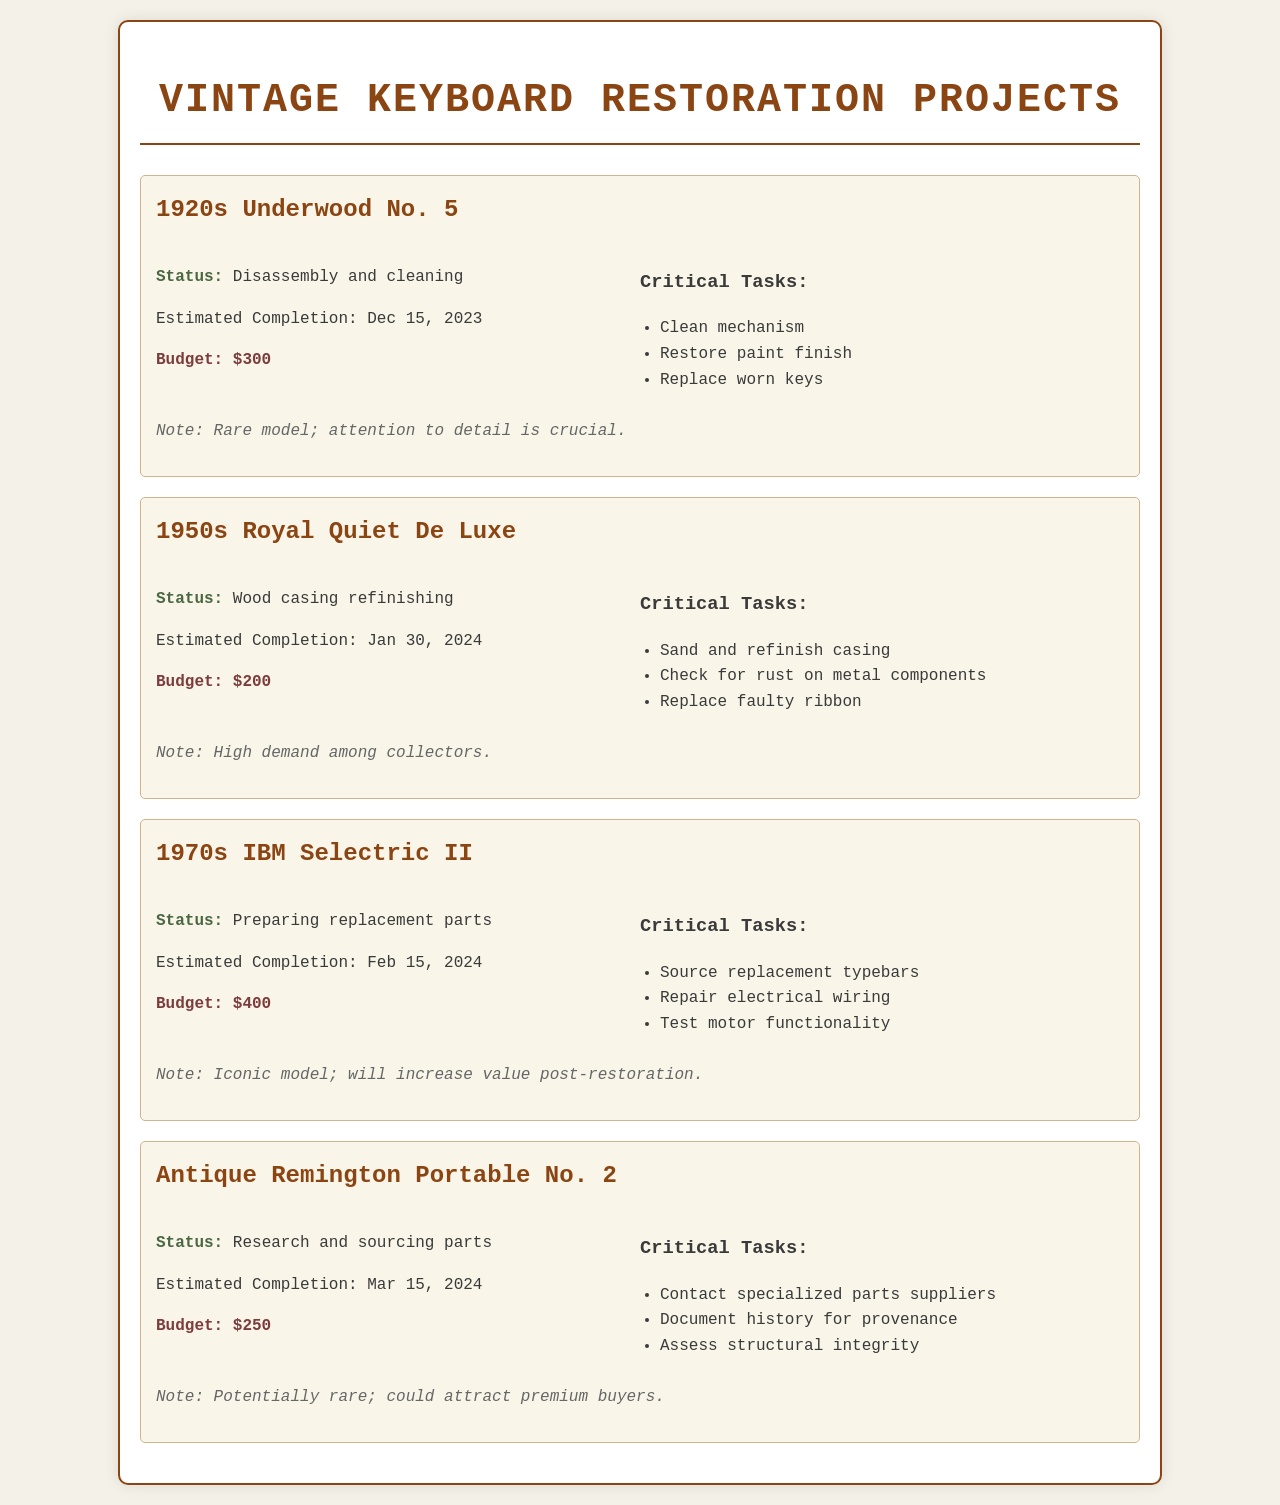what is the status of the 1920s Underwood No. 5? The status is indicated as the current phase of restoration in the document, which is "Disassembly and cleaning."
Answer: Disassembly and cleaning what is the estimated completion date for the 1950s Royal Quiet De Luxe? The estimated completion date is provided in the document, which states it will be completed on "Jan 30, 2024."
Answer: Jan 30, 2024 how much is allocated for the budget of the 1970s IBM Selectric II? The budget is specified in the project details as "$400."
Answer: $400 what critical task is associated with the Antique Remington Portable No. 2? Critical tasks are listed, one of which is "Contact specialized parts suppliers."
Answer: Contact specialized parts suppliers which project has the highest budget? The project with the highest budget can be identified by comparing the budget allocations given, which indicates that the "1970s IBM Selectric II" has a budget of $400.
Answer: 1970s IBM Selectric II what are the critical tasks for the 1950s Royal Quiet De Luxe? The document lists critical tasks, and one task is "Sand and refinish casing."
Answer: Sand and refinish casing what is the total budget for all projects listed? The total budget can be calculated by summing up the individual budgets stated in the document, which gives $300 + $200 + $400 + $250 = $1150.
Answer: $1150 what is the restoration phase for the 1970s IBM Selectric II? The restoration phase is described as "Preparing replacement parts" in the project details.
Answer: Preparing replacement parts which model is noted to be rare and requires attention to detail? The document specifically notes the "1920s Underwood No. 5" as being rare and requiring attention to detail.
Answer: 1920s Underwood No. 5 